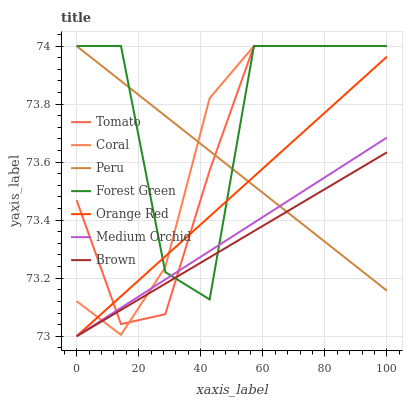Does Brown have the minimum area under the curve?
Answer yes or no. Yes. Does Forest Green have the maximum area under the curve?
Answer yes or no. Yes. Does Coral have the minimum area under the curve?
Answer yes or no. No. Does Coral have the maximum area under the curve?
Answer yes or no. No. Is Orange Red the smoothest?
Answer yes or no. Yes. Is Forest Green the roughest?
Answer yes or no. Yes. Is Brown the smoothest?
Answer yes or no. No. Is Brown the roughest?
Answer yes or no. No. Does Coral have the lowest value?
Answer yes or no. No. Does Peru have the highest value?
Answer yes or no. Yes. Does Brown have the highest value?
Answer yes or no. No. Does Peru intersect Forest Green?
Answer yes or no. Yes. Is Peru less than Forest Green?
Answer yes or no. No. Is Peru greater than Forest Green?
Answer yes or no. No. 